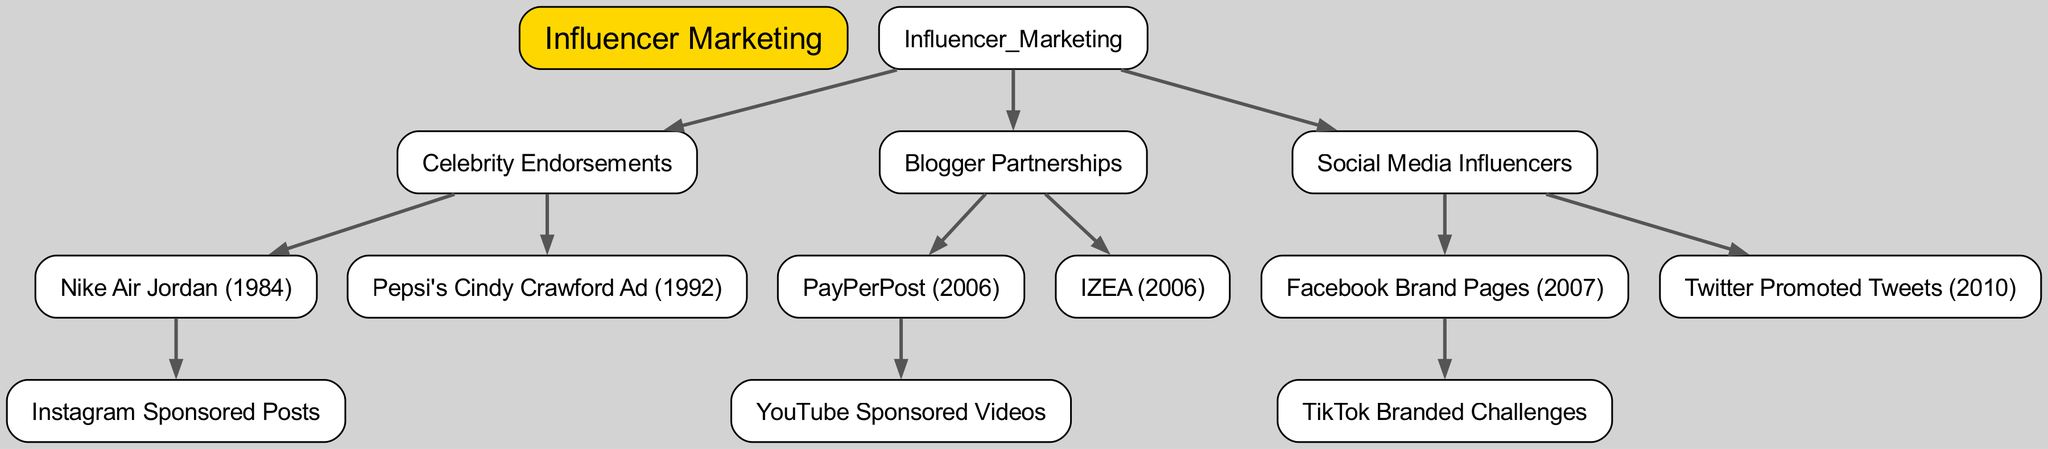What is the root of the family tree? The root of the tree, or the starting point, is labeled as "Influencer Marketing." This is the main category under which all other nodes are organized.
Answer: Influencer Marketing How many children does "Celebrity Endorsements" have? The node "Celebrity Endorsements" has two children nodes listed underneath it: "Nike Air Jordan (1984)" and "Pepsi's Cindy Crawford Ad (1992)." This indicates that there are a total of two direct descendants.
Answer: 2 Which node directly follows "Blogger Partnerships"? The node that directly follows "Blogger Partnerships" in the hierarchical structure is "Social Media Influencers." The diagram depicts this relationship as it moves from one category to the next.
Answer: Social Media Influencers What is the link between "Nike Air Jordan (1984)" and "Instagram Sponsored Posts"? "Instagram Sponsored Posts" is a child of "Nike Air Jordan (1984)," indicating that it is an evolution or a contemporary form of influencer marketing resulting from it. They are connected in a parent-child relationship in the diagram.
Answer: Instagram Sponsored Posts Which year did "PayPerPost" originate? The node "PayPerPost" is clearly labeled with the year "2006," indicating its inception. This information can be derived directly from the node's description.
Answer: 2006 What influences did "Facebook Brand Pages (2007)" lead to? The node "Facebook Brand Pages (2007)" leads to "TikTok Branded Challenges," representing a progression in influencer marketing methods that builds upon social media channels. This parent-child relationship signifies this influence.
Answer: TikTok Branded Challenges How many layers are in the tree from the root to the deepest child node? Counting the levels from the root "Influencer Marketing" down to its deepest leaf node, we have four distinct layers: root, children categories, sub-categories, and the ultimate child nodes (e.g., "Instagram Sponsored Posts").
Answer: 4 What relationship do "Twitter Promoted Tweets (2010)" and "Social Media Influencers" share? "Twitter Promoted Tweets (2010)" is a child node of the "Social Media Influencers" parent node, forming a direct relationship where "Social Media Influencers" encompasses it as a specialized strategy within influencer marketing.
Answer: Child Node Relationship What are the origins of "YouTube Sponsored Videos"? "YouTube Sponsored Videos" originates from "PayPerPost (2006)." The diagram shows this by depicting "YouTube Sponsored Videos" as a child of "PayPerPost." This indicates that it is a development that emerged from the earlier concept.
Answer: PayPerPost (2006) 